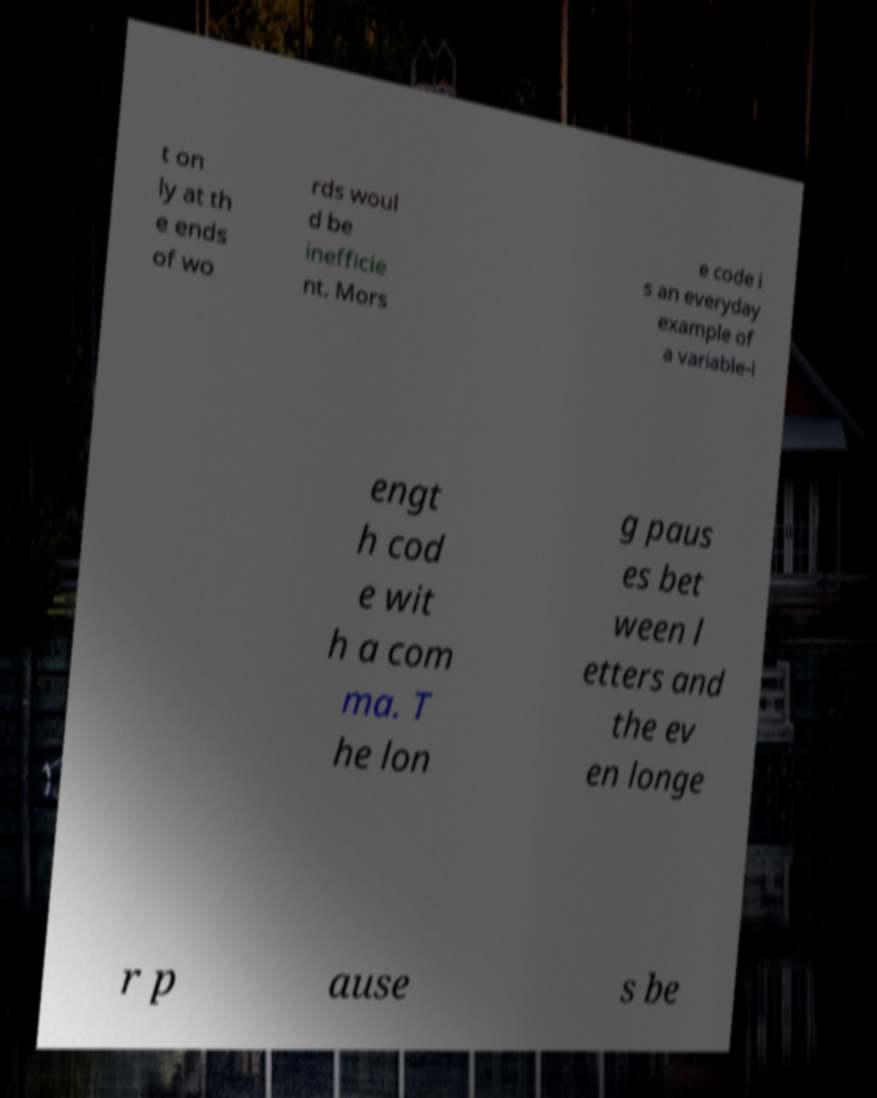There's text embedded in this image that I need extracted. Can you transcribe it verbatim? t on ly at th e ends of wo rds woul d be inefficie nt. Mors e code i s an everyday example of a variable-l engt h cod e wit h a com ma. T he lon g paus es bet ween l etters and the ev en longe r p ause s be 